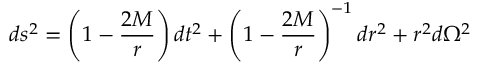Convert formula to latex. <formula><loc_0><loc_0><loc_500><loc_500>d s ^ { 2 } = \left ( 1 - { \frac { 2 M } { r } } \right ) d t ^ { 2 } + \left ( 1 - { \frac { 2 M } { r } } \right ) ^ { - 1 } d r ^ { 2 } + r ^ { 2 } d \Omega ^ { 2 }</formula> 